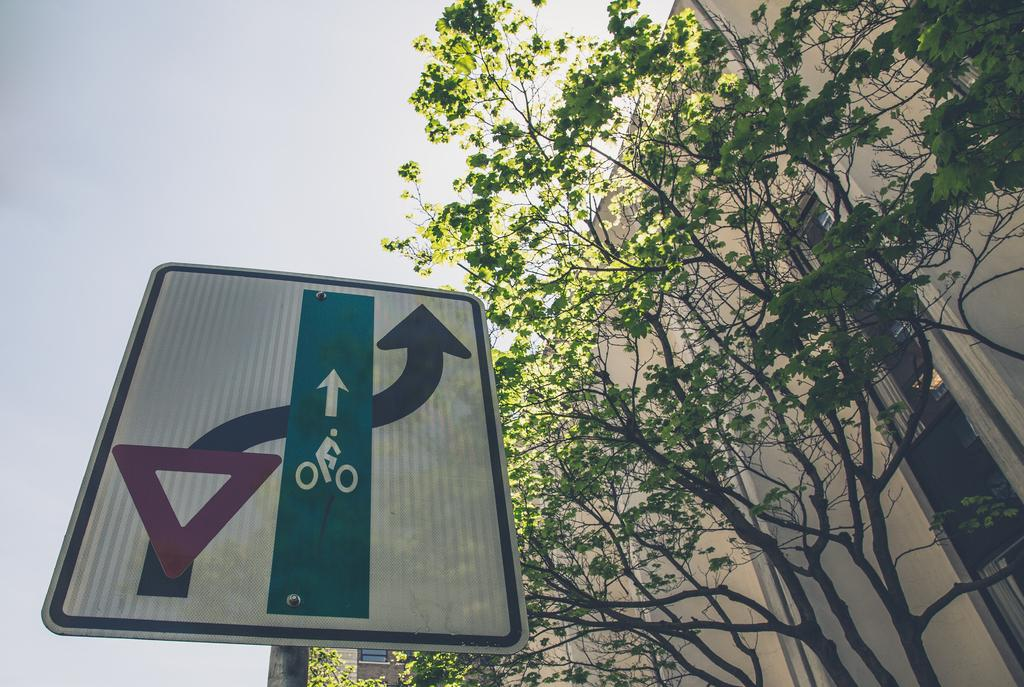What is attached to the pole in the image? There is a board attached to a pole in the image. What can be seen in the background of the image? There are trees and buildings in the background of the image. What is visible in the sky in the image? The sky is visible in the background of the image, and it appears to be plain. How many mice are sitting on the window in the image? There is no window or mice present in the image. What is the value of the cent in the image? There is no cent present in the image. 